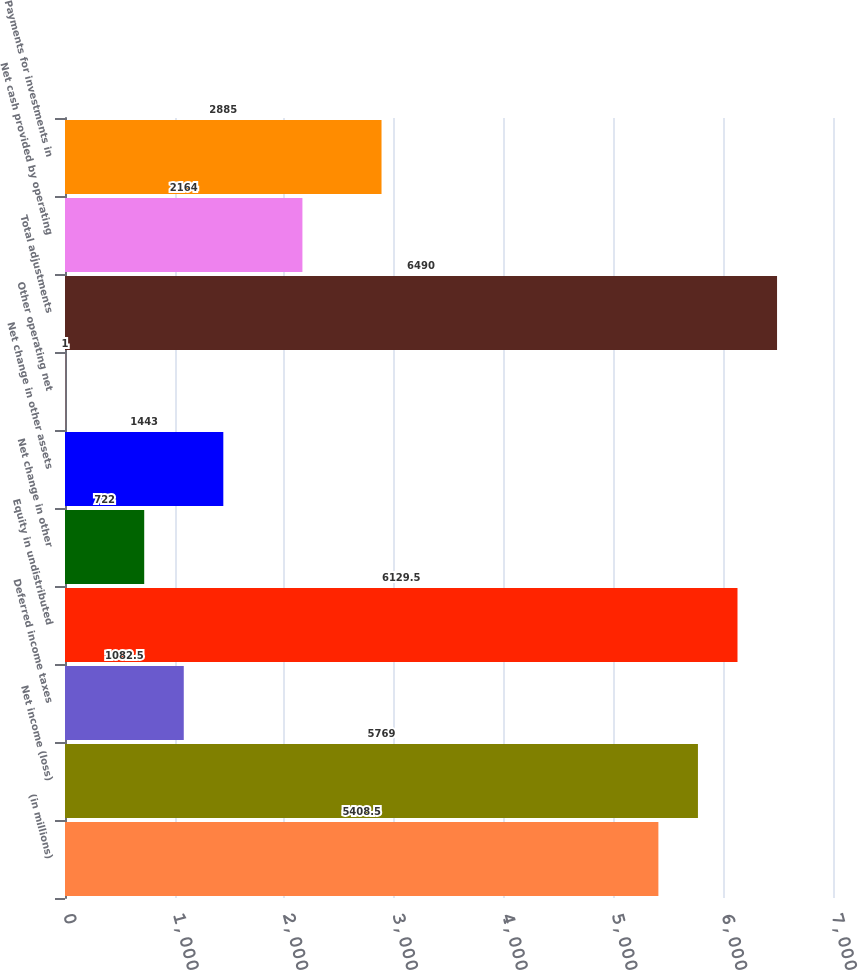<chart> <loc_0><loc_0><loc_500><loc_500><bar_chart><fcel>(in millions)<fcel>Net income (loss)<fcel>Deferred income taxes<fcel>Equity in undistributed<fcel>Net change in other<fcel>Net change in other assets<fcel>Other operating net<fcel>Total adjustments<fcel>Net cash provided by operating<fcel>Payments for investments in<nl><fcel>5408.5<fcel>5769<fcel>1082.5<fcel>6129.5<fcel>722<fcel>1443<fcel>1<fcel>6490<fcel>2164<fcel>2885<nl></chart> 